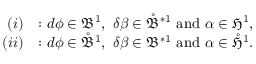Convert formula to latex. <formula><loc_0><loc_0><loc_500><loc_500>\begin{array} { r l } { ( i ) } & { \colon d \phi \in \mathfrak { B } ^ { 1 } , \ \delta \beta \in \mathring { \mathfrak { B } } ^ { \ast 1 } \ a n d \ \alpha \in \mathfrak { H } ^ { 1 } , } \\ { ( i i ) } & { \colon d \phi \in \mathring { \mathfrak { B } } ^ { 1 } , \ \delta \beta \in \mathfrak { B } ^ { \ast 1 } \ a n d \ \alpha \in \mathring { \mathfrak { H } } ^ { 1 } . } \end{array}</formula> 